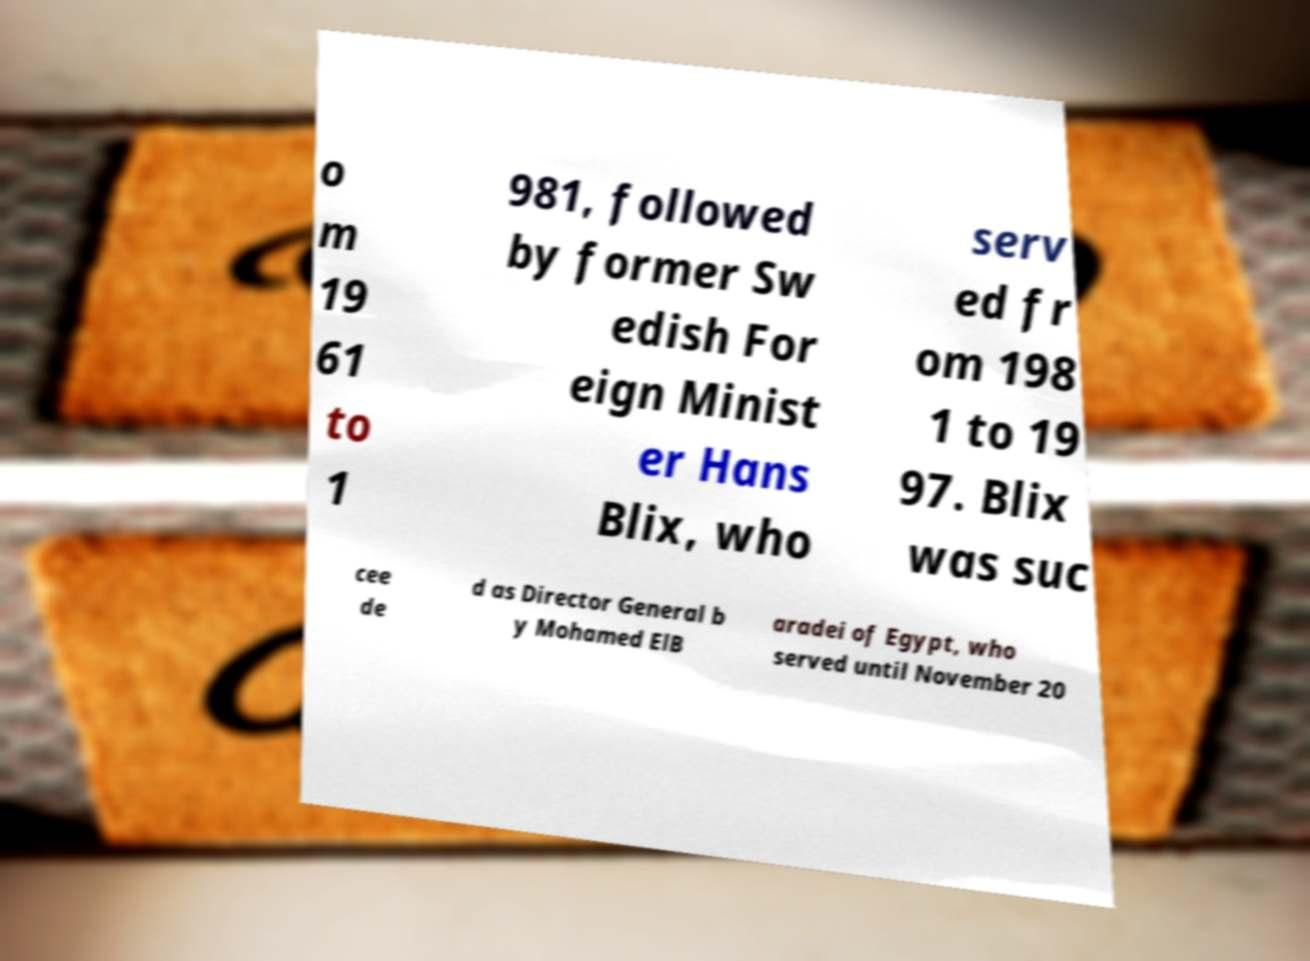Please read and relay the text visible in this image. What does it say? o m 19 61 to 1 981, followed by former Sw edish For eign Minist er Hans Blix, who serv ed fr om 198 1 to 19 97. Blix was suc cee de d as Director General b y Mohamed ElB aradei of Egypt, who served until November 20 